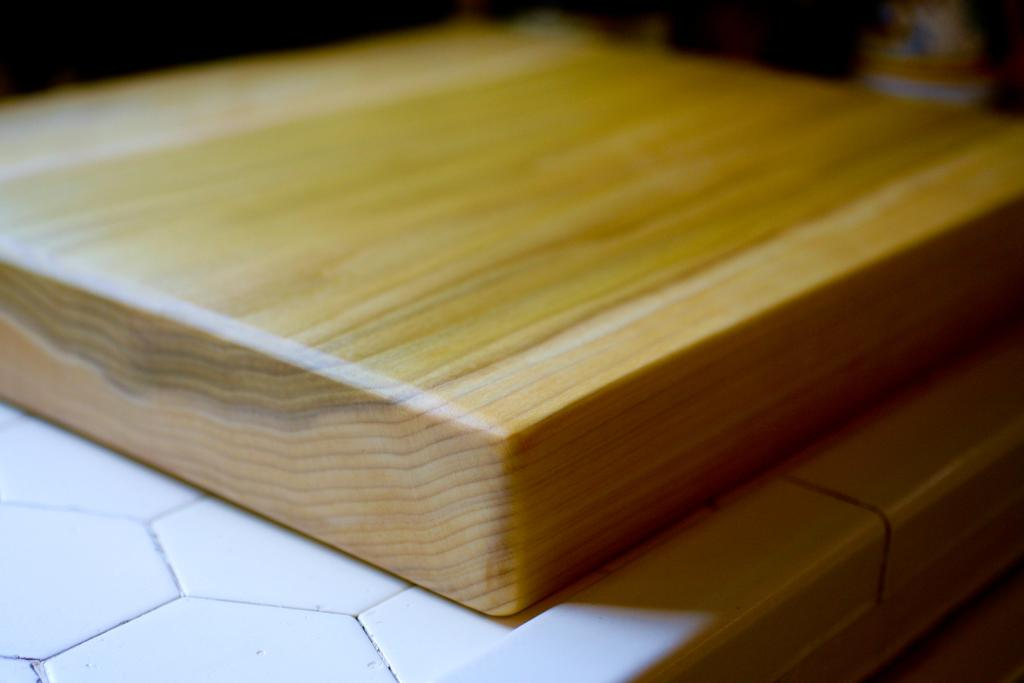What object is in the image? There is a wooden block in the image. On what surface is the wooden block placed? The wooden block is placed on a white surface. Can you describe the background of the image? The background of the image is blurred. How many goldfish are swimming in the wooden block in the image? There are no goldfish present in the image, as it features a wooden block on a white surface with a blurred background. 